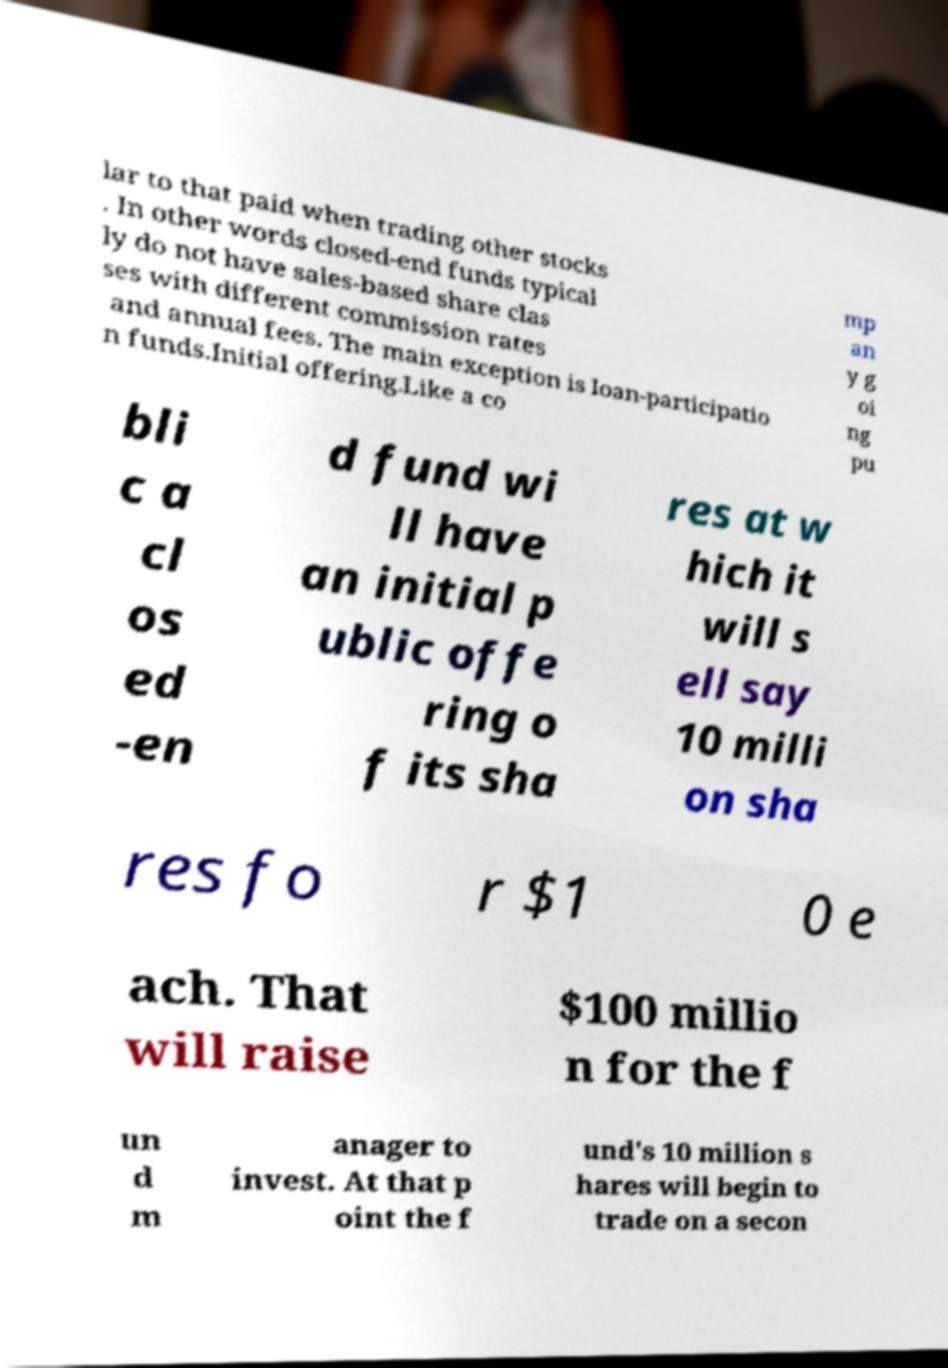There's text embedded in this image that I need extracted. Can you transcribe it verbatim? lar to that paid when trading other stocks . In other words closed-end funds typical ly do not have sales-based share clas ses with different commission rates and annual fees. The main exception is loan-participatio n funds.Initial offering.Like a co mp an y g oi ng pu bli c a cl os ed -en d fund wi ll have an initial p ublic offe ring o f its sha res at w hich it will s ell say 10 milli on sha res fo r $1 0 e ach. That will raise $100 millio n for the f un d m anager to invest. At that p oint the f und's 10 million s hares will begin to trade on a secon 